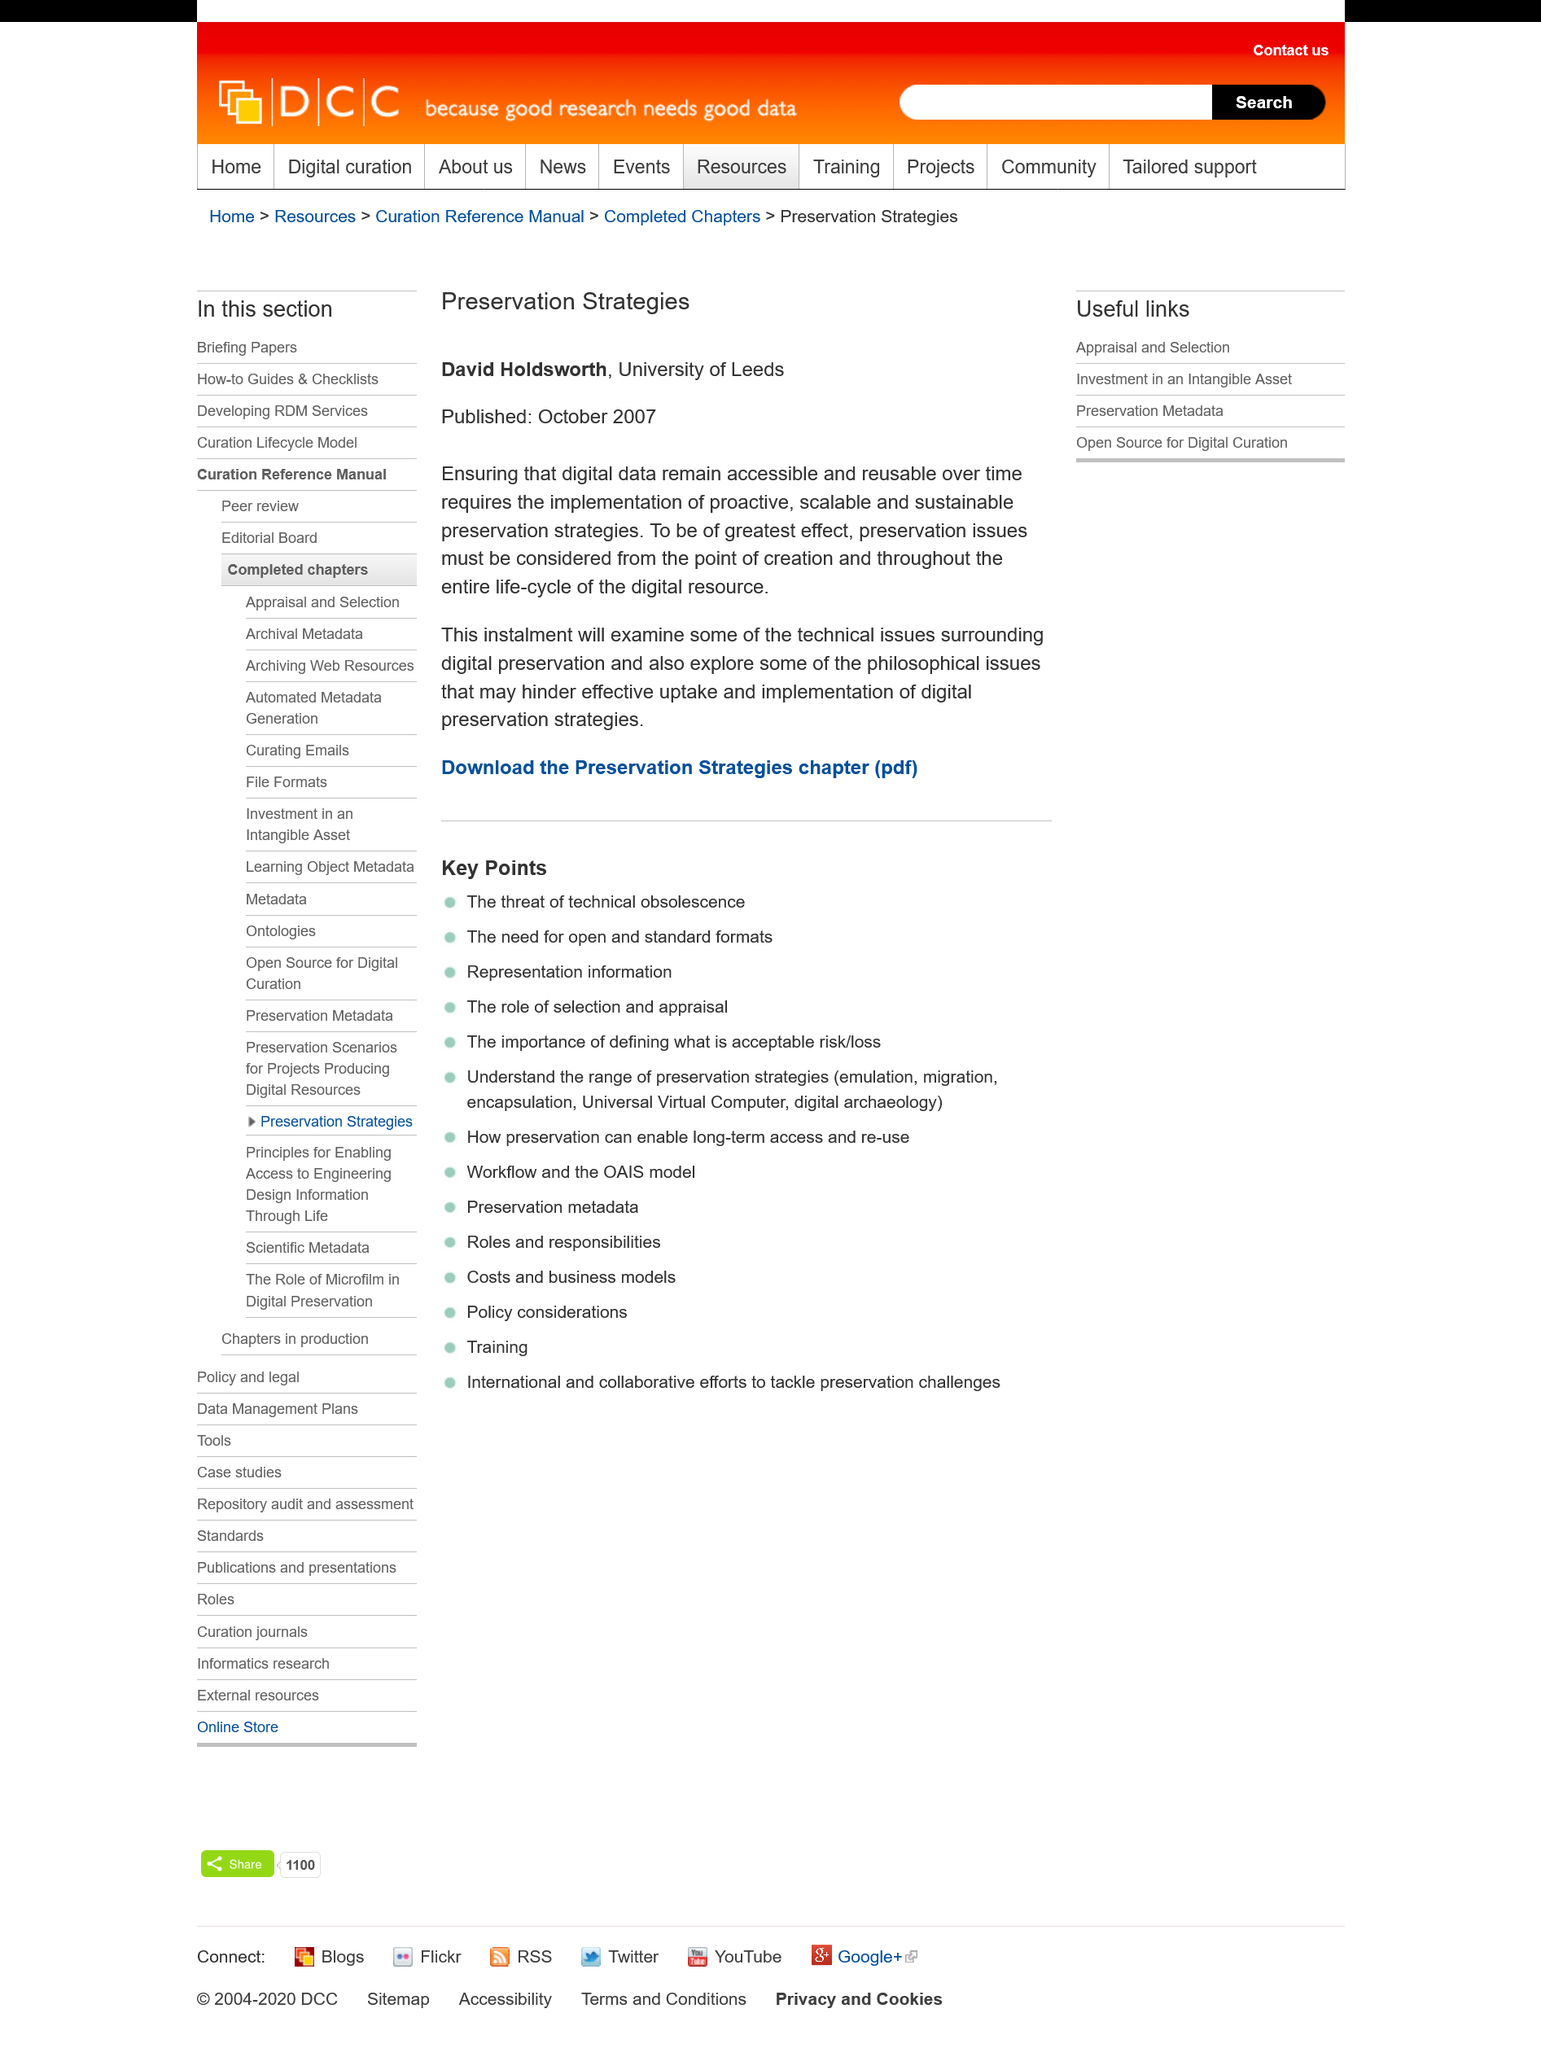Specify some key components in this picture. The article was published in October 2007. The article "Preservation Strategies" is authored by David Holdsworth. David Holdsworth is a student from the University of Leeds. 